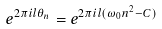<formula> <loc_0><loc_0><loc_500><loc_500>e ^ { 2 \pi i l \theta _ { n } } = e ^ { 2 \pi i l ( \omega _ { 0 } n ^ { 2 } - C ) }</formula> 